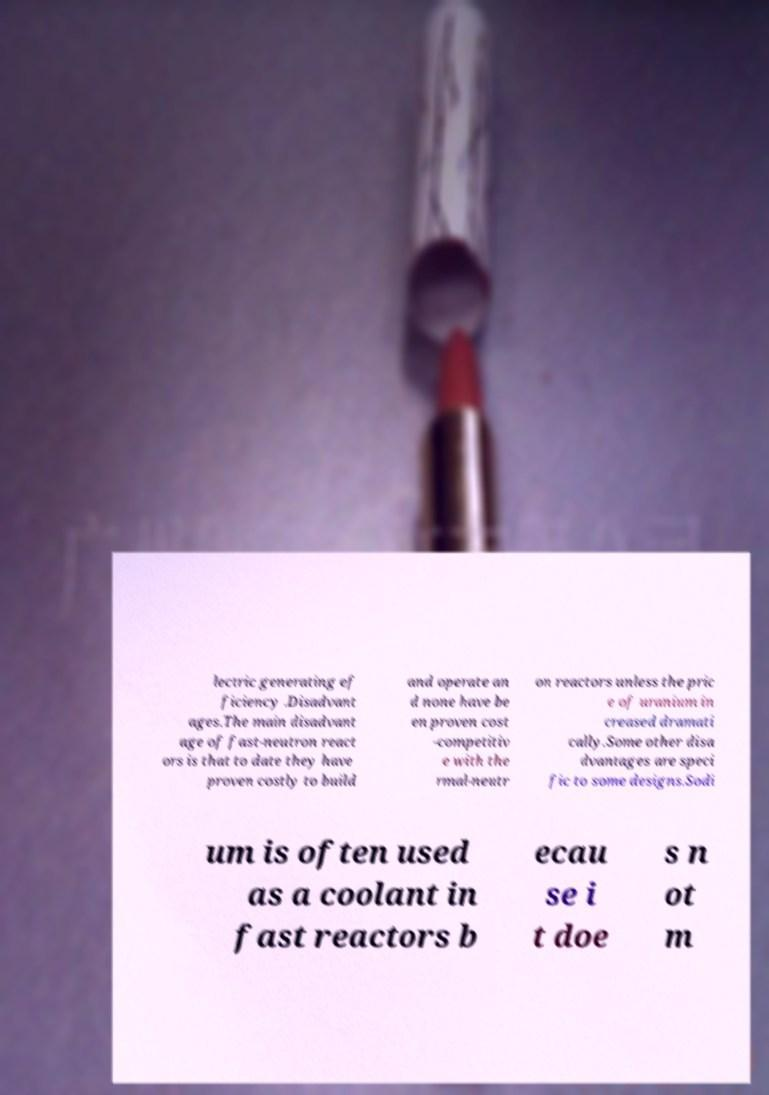What messages or text are displayed in this image? I need them in a readable, typed format. lectric generating ef ficiency .Disadvant ages.The main disadvant age of fast-neutron react ors is that to date they have proven costly to build and operate an d none have be en proven cost -competitiv e with the rmal-neutr on reactors unless the pric e of uranium in creased dramati cally.Some other disa dvantages are speci fic to some designs.Sodi um is often used as a coolant in fast reactors b ecau se i t doe s n ot m 